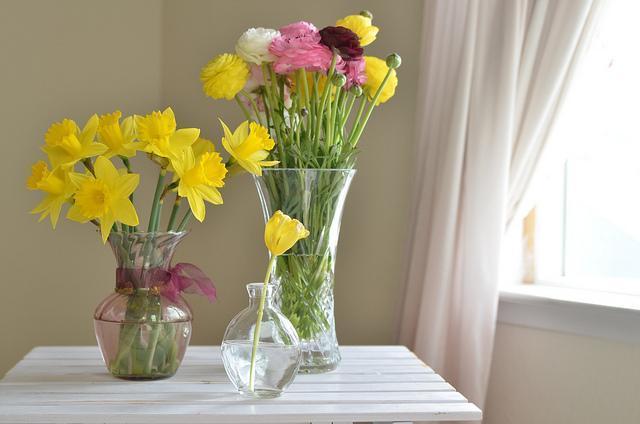How many vases are there?
Give a very brief answer. 3. How many potted plants are in the photo?
Give a very brief answer. 2. How many vases can be seen?
Give a very brief answer. 3. 